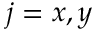Convert formula to latex. <formula><loc_0><loc_0><loc_500><loc_500>j = x , y</formula> 